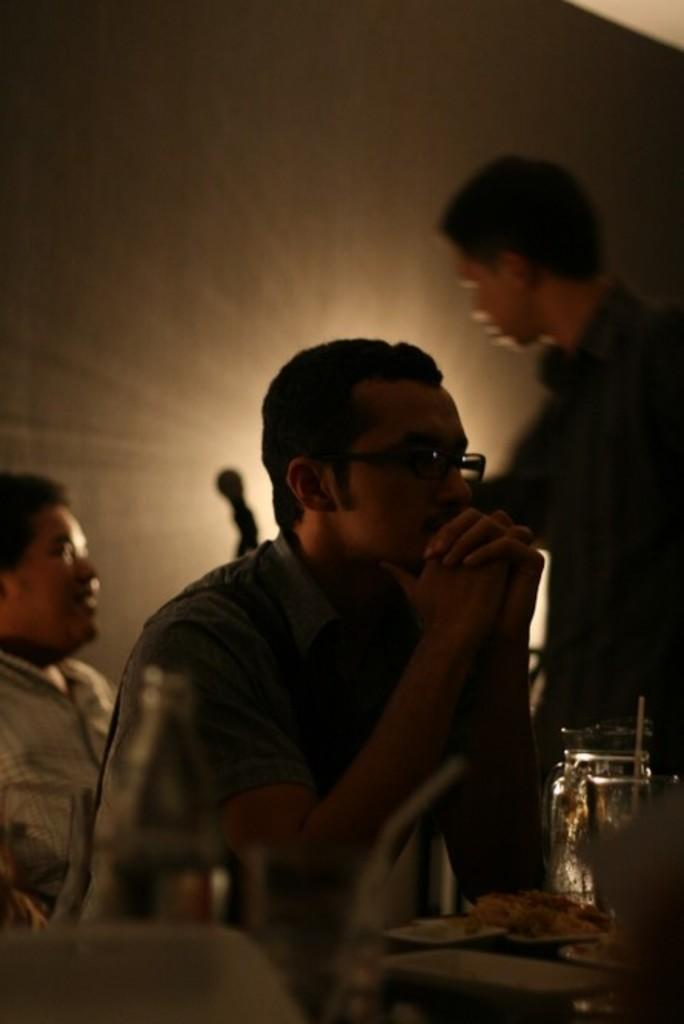Who or what is present in the image? There are people in the image. What type of objects can be seen in the image? There are glass objects and food items in the image. Where are the objects located in the image? There are objects at the bottom of the image. What type of beds can be seen in the image? There are no beds present in the image. How many seats are visible in the image? There is no mention of seats in the image, so it cannot be determined how many are visible. 